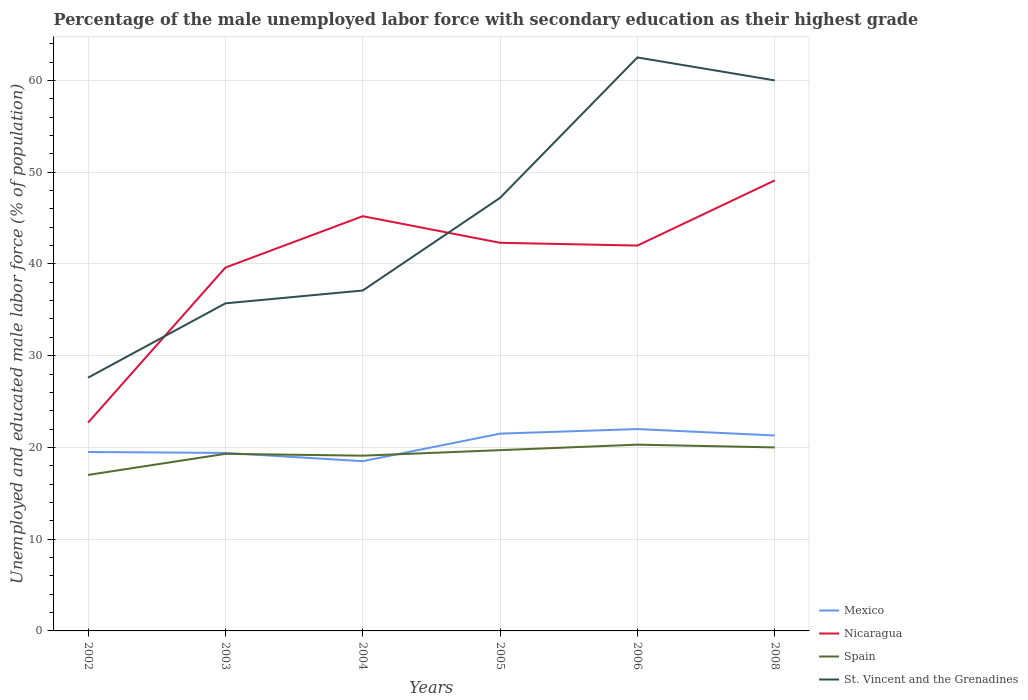How many different coloured lines are there?
Your answer should be very brief. 4. Across all years, what is the maximum percentage of the unemployed male labor force with secondary education in St. Vincent and the Grenadines?
Provide a short and direct response. 27.6. What is the total percentage of the unemployed male labor force with secondary education in Mexico in the graph?
Your response must be concise. 0.2. Is the percentage of the unemployed male labor force with secondary education in Mexico strictly greater than the percentage of the unemployed male labor force with secondary education in Spain over the years?
Give a very brief answer. No. How many years are there in the graph?
Ensure brevity in your answer.  6. Does the graph contain any zero values?
Your response must be concise. No. Where does the legend appear in the graph?
Offer a terse response. Bottom right. How are the legend labels stacked?
Your answer should be compact. Vertical. What is the title of the graph?
Offer a terse response. Percentage of the male unemployed labor force with secondary education as their highest grade. Does "Korea (Republic)" appear as one of the legend labels in the graph?
Provide a short and direct response. No. What is the label or title of the X-axis?
Provide a short and direct response. Years. What is the label or title of the Y-axis?
Your response must be concise. Unemployed and educated male labor force (% of population). What is the Unemployed and educated male labor force (% of population) of Nicaragua in 2002?
Offer a very short reply. 22.7. What is the Unemployed and educated male labor force (% of population) in St. Vincent and the Grenadines in 2002?
Offer a very short reply. 27.6. What is the Unemployed and educated male labor force (% of population) of Mexico in 2003?
Give a very brief answer. 19.4. What is the Unemployed and educated male labor force (% of population) in Nicaragua in 2003?
Your answer should be compact. 39.6. What is the Unemployed and educated male labor force (% of population) of Spain in 2003?
Your response must be concise. 19.3. What is the Unemployed and educated male labor force (% of population) of St. Vincent and the Grenadines in 2003?
Offer a terse response. 35.7. What is the Unemployed and educated male labor force (% of population) in Nicaragua in 2004?
Your response must be concise. 45.2. What is the Unemployed and educated male labor force (% of population) in Spain in 2004?
Your answer should be compact. 19.1. What is the Unemployed and educated male labor force (% of population) of St. Vincent and the Grenadines in 2004?
Provide a succinct answer. 37.1. What is the Unemployed and educated male labor force (% of population) in Nicaragua in 2005?
Your answer should be compact. 42.3. What is the Unemployed and educated male labor force (% of population) of Spain in 2005?
Your answer should be very brief. 19.7. What is the Unemployed and educated male labor force (% of population) in St. Vincent and the Grenadines in 2005?
Offer a very short reply. 47.2. What is the Unemployed and educated male labor force (% of population) of Spain in 2006?
Your answer should be compact. 20.3. What is the Unemployed and educated male labor force (% of population) in St. Vincent and the Grenadines in 2006?
Your answer should be compact. 62.5. What is the Unemployed and educated male labor force (% of population) of Mexico in 2008?
Your response must be concise. 21.3. What is the Unemployed and educated male labor force (% of population) in Nicaragua in 2008?
Offer a very short reply. 49.1. Across all years, what is the maximum Unemployed and educated male labor force (% of population) in Nicaragua?
Make the answer very short. 49.1. Across all years, what is the maximum Unemployed and educated male labor force (% of population) in Spain?
Your answer should be compact. 20.3. Across all years, what is the maximum Unemployed and educated male labor force (% of population) in St. Vincent and the Grenadines?
Your response must be concise. 62.5. Across all years, what is the minimum Unemployed and educated male labor force (% of population) of Nicaragua?
Your answer should be compact. 22.7. Across all years, what is the minimum Unemployed and educated male labor force (% of population) of Spain?
Your answer should be very brief. 17. Across all years, what is the minimum Unemployed and educated male labor force (% of population) in St. Vincent and the Grenadines?
Your answer should be very brief. 27.6. What is the total Unemployed and educated male labor force (% of population) of Mexico in the graph?
Offer a terse response. 122.2. What is the total Unemployed and educated male labor force (% of population) in Nicaragua in the graph?
Keep it short and to the point. 240.9. What is the total Unemployed and educated male labor force (% of population) in Spain in the graph?
Make the answer very short. 115.4. What is the total Unemployed and educated male labor force (% of population) of St. Vincent and the Grenadines in the graph?
Offer a terse response. 270.1. What is the difference between the Unemployed and educated male labor force (% of population) of Mexico in 2002 and that in 2003?
Your answer should be compact. 0.1. What is the difference between the Unemployed and educated male labor force (% of population) of Nicaragua in 2002 and that in 2003?
Ensure brevity in your answer.  -16.9. What is the difference between the Unemployed and educated male labor force (% of population) in Spain in 2002 and that in 2003?
Make the answer very short. -2.3. What is the difference between the Unemployed and educated male labor force (% of population) of St. Vincent and the Grenadines in 2002 and that in 2003?
Provide a short and direct response. -8.1. What is the difference between the Unemployed and educated male labor force (% of population) of Nicaragua in 2002 and that in 2004?
Provide a short and direct response. -22.5. What is the difference between the Unemployed and educated male labor force (% of population) of St. Vincent and the Grenadines in 2002 and that in 2004?
Your answer should be compact. -9.5. What is the difference between the Unemployed and educated male labor force (% of population) of Nicaragua in 2002 and that in 2005?
Offer a very short reply. -19.6. What is the difference between the Unemployed and educated male labor force (% of population) in St. Vincent and the Grenadines in 2002 and that in 2005?
Your answer should be very brief. -19.6. What is the difference between the Unemployed and educated male labor force (% of population) of Nicaragua in 2002 and that in 2006?
Provide a succinct answer. -19.3. What is the difference between the Unemployed and educated male labor force (% of population) in Spain in 2002 and that in 2006?
Give a very brief answer. -3.3. What is the difference between the Unemployed and educated male labor force (% of population) in St. Vincent and the Grenadines in 2002 and that in 2006?
Give a very brief answer. -34.9. What is the difference between the Unemployed and educated male labor force (% of population) of Mexico in 2002 and that in 2008?
Ensure brevity in your answer.  -1.8. What is the difference between the Unemployed and educated male labor force (% of population) in Nicaragua in 2002 and that in 2008?
Provide a succinct answer. -26.4. What is the difference between the Unemployed and educated male labor force (% of population) of St. Vincent and the Grenadines in 2002 and that in 2008?
Give a very brief answer. -32.4. What is the difference between the Unemployed and educated male labor force (% of population) in Mexico in 2003 and that in 2005?
Your answer should be very brief. -2.1. What is the difference between the Unemployed and educated male labor force (% of population) in Nicaragua in 2003 and that in 2005?
Your answer should be very brief. -2.7. What is the difference between the Unemployed and educated male labor force (% of population) of Spain in 2003 and that in 2005?
Give a very brief answer. -0.4. What is the difference between the Unemployed and educated male labor force (% of population) in Mexico in 2003 and that in 2006?
Ensure brevity in your answer.  -2.6. What is the difference between the Unemployed and educated male labor force (% of population) of St. Vincent and the Grenadines in 2003 and that in 2006?
Keep it short and to the point. -26.8. What is the difference between the Unemployed and educated male labor force (% of population) of Mexico in 2003 and that in 2008?
Your response must be concise. -1.9. What is the difference between the Unemployed and educated male labor force (% of population) of Nicaragua in 2003 and that in 2008?
Keep it short and to the point. -9.5. What is the difference between the Unemployed and educated male labor force (% of population) of St. Vincent and the Grenadines in 2003 and that in 2008?
Give a very brief answer. -24.3. What is the difference between the Unemployed and educated male labor force (% of population) of Nicaragua in 2004 and that in 2005?
Your answer should be compact. 2.9. What is the difference between the Unemployed and educated male labor force (% of population) in Spain in 2004 and that in 2005?
Make the answer very short. -0.6. What is the difference between the Unemployed and educated male labor force (% of population) of Mexico in 2004 and that in 2006?
Offer a terse response. -3.5. What is the difference between the Unemployed and educated male labor force (% of population) in St. Vincent and the Grenadines in 2004 and that in 2006?
Ensure brevity in your answer.  -25.4. What is the difference between the Unemployed and educated male labor force (% of population) in Nicaragua in 2004 and that in 2008?
Give a very brief answer. -3.9. What is the difference between the Unemployed and educated male labor force (% of population) of Spain in 2004 and that in 2008?
Offer a terse response. -0.9. What is the difference between the Unemployed and educated male labor force (% of population) in St. Vincent and the Grenadines in 2004 and that in 2008?
Provide a short and direct response. -22.9. What is the difference between the Unemployed and educated male labor force (% of population) of Mexico in 2005 and that in 2006?
Give a very brief answer. -0.5. What is the difference between the Unemployed and educated male labor force (% of population) of Nicaragua in 2005 and that in 2006?
Your answer should be very brief. 0.3. What is the difference between the Unemployed and educated male labor force (% of population) in Spain in 2005 and that in 2006?
Offer a very short reply. -0.6. What is the difference between the Unemployed and educated male labor force (% of population) in St. Vincent and the Grenadines in 2005 and that in 2006?
Offer a terse response. -15.3. What is the difference between the Unemployed and educated male labor force (% of population) of Mexico in 2005 and that in 2008?
Offer a very short reply. 0.2. What is the difference between the Unemployed and educated male labor force (% of population) in Nicaragua in 2005 and that in 2008?
Ensure brevity in your answer.  -6.8. What is the difference between the Unemployed and educated male labor force (% of population) of St. Vincent and the Grenadines in 2005 and that in 2008?
Keep it short and to the point. -12.8. What is the difference between the Unemployed and educated male labor force (% of population) in Nicaragua in 2006 and that in 2008?
Your answer should be compact. -7.1. What is the difference between the Unemployed and educated male labor force (% of population) in Mexico in 2002 and the Unemployed and educated male labor force (% of population) in Nicaragua in 2003?
Your answer should be compact. -20.1. What is the difference between the Unemployed and educated male labor force (% of population) of Mexico in 2002 and the Unemployed and educated male labor force (% of population) of St. Vincent and the Grenadines in 2003?
Ensure brevity in your answer.  -16.2. What is the difference between the Unemployed and educated male labor force (% of population) of Nicaragua in 2002 and the Unemployed and educated male labor force (% of population) of Spain in 2003?
Offer a very short reply. 3.4. What is the difference between the Unemployed and educated male labor force (% of population) of Spain in 2002 and the Unemployed and educated male labor force (% of population) of St. Vincent and the Grenadines in 2003?
Your response must be concise. -18.7. What is the difference between the Unemployed and educated male labor force (% of population) of Mexico in 2002 and the Unemployed and educated male labor force (% of population) of Nicaragua in 2004?
Provide a succinct answer. -25.7. What is the difference between the Unemployed and educated male labor force (% of population) in Mexico in 2002 and the Unemployed and educated male labor force (% of population) in St. Vincent and the Grenadines in 2004?
Your response must be concise. -17.6. What is the difference between the Unemployed and educated male labor force (% of population) of Nicaragua in 2002 and the Unemployed and educated male labor force (% of population) of St. Vincent and the Grenadines in 2004?
Provide a short and direct response. -14.4. What is the difference between the Unemployed and educated male labor force (% of population) in Spain in 2002 and the Unemployed and educated male labor force (% of population) in St. Vincent and the Grenadines in 2004?
Your response must be concise. -20.1. What is the difference between the Unemployed and educated male labor force (% of population) in Mexico in 2002 and the Unemployed and educated male labor force (% of population) in Nicaragua in 2005?
Provide a short and direct response. -22.8. What is the difference between the Unemployed and educated male labor force (% of population) of Mexico in 2002 and the Unemployed and educated male labor force (% of population) of Spain in 2005?
Your answer should be compact. -0.2. What is the difference between the Unemployed and educated male labor force (% of population) of Mexico in 2002 and the Unemployed and educated male labor force (% of population) of St. Vincent and the Grenadines in 2005?
Offer a terse response. -27.7. What is the difference between the Unemployed and educated male labor force (% of population) of Nicaragua in 2002 and the Unemployed and educated male labor force (% of population) of St. Vincent and the Grenadines in 2005?
Your answer should be compact. -24.5. What is the difference between the Unemployed and educated male labor force (% of population) in Spain in 2002 and the Unemployed and educated male labor force (% of population) in St. Vincent and the Grenadines in 2005?
Ensure brevity in your answer.  -30.2. What is the difference between the Unemployed and educated male labor force (% of population) of Mexico in 2002 and the Unemployed and educated male labor force (% of population) of Nicaragua in 2006?
Make the answer very short. -22.5. What is the difference between the Unemployed and educated male labor force (% of population) of Mexico in 2002 and the Unemployed and educated male labor force (% of population) of Spain in 2006?
Your answer should be very brief. -0.8. What is the difference between the Unemployed and educated male labor force (% of population) in Mexico in 2002 and the Unemployed and educated male labor force (% of population) in St. Vincent and the Grenadines in 2006?
Offer a very short reply. -43. What is the difference between the Unemployed and educated male labor force (% of population) of Nicaragua in 2002 and the Unemployed and educated male labor force (% of population) of St. Vincent and the Grenadines in 2006?
Ensure brevity in your answer.  -39.8. What is the difference between the Unemployed and educated male labor force (% of population) of Spain in 2002 and the Unemployed and educated male labor force (% of population) of St. Vincent and the Grenadines in 2006?
Offer a very short reply. -45.5. What is the difference between the Unemployed and educated male labor force (% of population) of Mexico in 2002 and the Unemployed and educated male labor force (% of population) of Nicaragua in 2008?
Give a very brief answer. -29.6. What is the difference between the Unemployed and educated male labor force (% of population) in Mexico in 2002 and the Unemployed and educated male labor force (% of population) in St. Vincent and the Grenadines in 2008?
Ensure brevity in your answer.  -40.5. What is the difference between the Unemployed and educated male labor force (% of population) in Nicaragua in 2002 and the Unemployed and educated male labor force (% of population) in Spain in 2008?
Ensure brevity in your answer.  2.7. What is the difference between the Unemployed and educated male labor force (% of population) in Nicaragua in 2002 and the Unemployed and educated male labor force (% of population) in St. Vincent and the Grenadines in 2008?
Your answer should be compact. -37.3. What is the difference between the Unemployed and educated male labor force (% of population) in Spain in 2002 and the Unemployed and educated male labor force (% of population) in St. Vincent and the Grenadines in 2008?
Your answer should be very brief. -43. What is the difference between the Unemployed and educated male labor force (% of population) of Mexico in 2003 and the Unemployed and educated male labor force (% of population) of Nicaragua in 2004?
Make the answer very short. -25.8. What is the difference between the Unemployed and educated male labor force (% of population) in Mexico in 2003 and the Unemployed and educated male labor force (% of population) in St. Vincent and the Grenadines in 2004?
Keep it short and to the point. -17.7. What is the difference between the Unemployed and educated male labor force (% of population) in Nicaragua in 2003 and the Unemployed and educated male labor force (% of population) in Spain in 2004?
Give a very brief answer. 20.5. What is the difference between the Unemployed and educated male labor force (% of population) of Nicaragua in 2003 and the Unemployed and educated male labor force (% of population) of St. Vincent and the Grenadines in 2004?
Make the answer very short. 2.5. What is the difference between the Unemployed and educated male labor force (% of population) of Spain in 2003 and the Unemployed and educated male labor force (% of population) of St. Vincent and the Grenadines in 2004?
Your answer should be very brief. -17.8. What is the difference between the Unemployed and educated male labor force (% of population) of Mexico in 2003 and the Unemployed and educated male labor force (% of population) of Nicaragua in 2005?
Your response must be concise. -22.9. What is the difference between the Unemployed and educated male labor force (% of population) in Mexico in 2003 and the Unemployed and educated male labor force (% of population) in St. Vincent and the Grenadines in 2005?
Give a very brief answer. -27.8. What is the difference between the Unemployed and educated male labor force (% of population) of Nicaragua in 2003 and the Unemployed and educated male labor force (% of population) of Spain in 2005?
Provide a succinct answer. 19.9. What is the difference between the Unemployed and educated male labor force (% of population) of Spain in 2003 and the Unemployed and educated male labor force (% of population) of St. Vincent and the Grenadines in 2005?
Provide a short and direct response. -27.9. What is the difference between the Unemployed and educated male labor force (% of population) of Mexico in 2003 and the Unemployed and educated male labor force (% of population) of Nicaragua in 2006?
Keep it short and to the point. -22.6. What is the difference between the Unemployed and educated male labor force (% of population) of Mexico in 2003 and the Unemployed and educated male labor force (% of population) of St. Vincent and the Grenadines in 2006?
Keep it short and to the point. -43.1. What is the difference between the Unemployed and educated male labor force (% of population) in Nicaragua in 2003 and the Unemployed and educated male labor force (% of population) in Spain in 2006?
Your response must be concise. 19.3. What is the difference between the Unemployed and educated male labor force (% of population) of Nicaragua in 2003 and the Unemployed and educated male labor force (% of population) of St. Vincent and the Grenadines in 2006?
Provide a short and direct response. -22.9. What is the difference between the Unemployed and educated male labor force (% of population) of Spain in 2003 and the Unemployed and educated male labor force (% of population) of St. Vincent and the Grenadines in 2006?
Give a very brief answer. -43.2. What is the difference between the Unemployed and educated male labor force (% of population) of Mexico in 2003 and the Unemployed and educated male labor force (% of population) of Nicaragua in 2008?
Keep it short and to the point. -29.7. What is the difference between the Unemployed and educated male labor force (% of population) of Mexico in 2003 and the Unemployed and educated male labor force (% of population) of Spain in 2008?
Your answer should be very brief. -0.6. What is the difference between the Unemployed and educated male labor force (% of population) of Mexico in 2003 and the Unemployed and educated male labor force (% of population) of St. Vincent and the Grenadines in 2008?
Provide a succinct answer. -40.6. What is the difference between the Unemployed and educated male labor force (% of population) in Nicaragua in 2003 and the Unemployed and educated male labor force (% of population) in Spain in 2008?
Offer a terse response. 19.6. What is the difference between the Unemployed and educated male labor force (% of population) of Nicaragua in 2003 and the Unemployed and educated male labor force (% of population) of St. Vincent and the Grenadines in 2008?
Provide a short and direct response. -20.4. What is the difference between the Unemployed and educated male labor force (% of population) of Spain in 2003 and the Unemployed and educated male labor force (% of population) of St. Vincent and the Grenadines in 2008?
Make the answer very short. -40.7. What is the difference between the Unemployed and educated male labor force (% of population) of Mexico in 2004 and the Unemployed and educated male labor force (% of population) of Nicaragua in 2005?
Provide a short and direct response. -23.8. What is the difference between the Unemployed and educated male labor force (% of population) of Mexico in 2004 and the Unemployed and educated male labor force (% of population) of St. Vincent and the Grenadines in 2005?
Offer a very short reply. -28.7. What is the difference between the Unemployed and educated male labor force (% of population) of Spain in 2004 and the Unemployed and educated male labor force (% of population) of St. Vincent and the Grenadines in 2005?
Make the answer very short. -28.1. What is the difference between the Unemployed and educated male labor force (% of population) of Mexico in 2004 and the Unemployed and educated male labor force (% of population) of Nicaragua in 2006?
Make the answer very short. -23.5. What is the difference between the Unemployed and educated male labor force (% of population) in Mexico in 2004 and the Unemployed and educated male labor force (% of population) in St. Vincent and the Grenadines in 2006?
Give a very brief answer. -44. What is the difference between the Unemployed and educated male labor force (% of population) of Nicaragua in 2004 and the Unemployed and educated male labor force (% of population) of Spain in 2006?
Your response must be concise. 24.9. What is the difference between the Unemployed and educated male labor force (% of population) in Nicaragua in 2004 and the Unemployed and educated male labor force (% of population) in St. Vincent and the Grenadines in 2006?
Make the answer very short. -17.3. What is the difference between the Unemployed and educated male labor force (% of population) in Spain in 2004 and the Unemployed and educated male labor force (% of population) in St. Vincent and the Grenadines in 2006?
Your response must be concise. -43.4. What is the difference between the Unemployed and educated male labor force (% of population) in Mexico in 2004 and the Unemployed and educated male labor force (% of population) in Nicaragua in 2008?
Your answer should be compact. -30.6. What is the difference between the Unemployed and educated male labor force (% of population) in Mexico in 2004 and the Unemployed and educated male labor force (% of population) in Spain in 2008?
Give a very brief answer. -1.5. What is the difference between the Unemployed and educated male labor force (% of population) in Mexico in 2004 and the Unemployed and educated male labor force (% of population) in St. Vincent and the Grenadines in 2008?
Your answer should be very brief. -41.5. What is the difference between the Unemployed and educated male labor force (% of population) of Nicaragua in 2004 and the Unemployed and educated male labor force (% of population) of Spain in 2008?
Offer a terse response. 25.2. What is the difference between the Unemployed and educated male labor force (% of population) in Nicaragua in 2004 and the Unemployed and educated male labor force (% of population) in St. Vincent and the Grenadines in 2008?
Provide a short and direct response. -14.8. What is the difference between the Unemployed and educated male labor force (% of population) of Spain in 2004 and the Unemployed and educated male labor force (% of population) of St. Vincent and the Grenadines in 2008?
Ensure brevity in your answer.  -40.9. What is the difference between the Unemployed and educated male labor force (% of population) in Mexico in 2005 and the Unemployed and educated male labor force (% of population) in Nicaragua in 2006?
Give a very brief answer. -20.5. What is the difference between the Unemployed and educated male labor force (% of population) of Mexico in 2005 and the Unemployed and educated male labor force (% of population) of St. Vincent and the Grenadines in 2006?
Your answer should be very brief. -41. What is the difference between the Unemployed and educated male labor force (% of population) of Nicaragua in 2005 and the Unemployed and educated male labor force (% of population) of St. Vincent and the Grenadines in 2006?
Provide a short and direct response. -20.2. What is the difference between the Unemployed and educated male labor force (% of population) in Spain in 2005 and the Unemployed and educated male labor force (% of population) in St. Vincent and the Grenadines in 2006?
Ensure brevity in your answer.  -42.8. What is the difference between the Unemployed and educated male labor force (% of population) in Mexico in 2005 and the Unemployed and educated male labor force (% of population) in Nicaragua in 2008?
Provide a succinct answer. -27.6. What is the difference between the Unemployed and educated male labor force (% of population) of Mexico in 2005 and the Unemployed and educated male labor force (% of population) of Spain in 2008?
Ensure brevity in your answer.  1.5. What is the difference between the Unemployed and educated male labor force (% of population) in Mexico in 2005 and the Unemployed and educated male labor force (% of population) in St. Vincent and the Grenadines in 2008?
Ensure brevity in your answer.  -38.5. What is the difference between the Unemployed and educated male labor force (% of population) in Nicaragua in 2005 and the Unemployed and educated male labor force (% of population) in Spain in 2008?
Offer a terse response. 22.3. What is the difference between the Unemployed and educated male labor force (% of population) of Nicaragua in 2005 and the Unemployed and educated male labor force (% of population) of St. Vincent and the Grenadines in 2008?
Give a very brief answer. -17.7. What is the difference between the Unemployed and educated male labor force (% of population) of Spain in 2005 and the Unemployed and educated male labor force (% of population) of St. Vincent and the Grenadines in 2008?
Your response must be concise. -40.3. What is the difference between the Unemployed and educated male labor force (% of population) of Mexico in 2006 and the Unemployed and educated male labor force (% of population) of Nicaragua in 2008?
Your answer should be very brief. -27.1. What is the difference between the Unemployed and educated male labor force (% of population) of Mexico in 2006 and the Unemployed and educated male labor force (% of population) of Spain in 2008?
Provide a short and direct response. 2. What is the difference between the Unemployed and educated male labor force (% of population) of Mexico in 2006 and the Unemployed and educated male labor force (% of population) of St. Vincent and the Grenadines in 2008?
Provide a short and direct response. -38. What is the difference between the Unemployed and educated male labor force (% of population) of Spain in 2006 and the Unemployed and educated male labor force (% of population) of St. Vincent and the Grenadines in 2008?
Your response must be concise. -39.7. What is the average Unemployed and educated male labor force (% of population) of Mexico per year?
Keep it short and to the point. 20.37. What is the average Unemployed and educated male labor force (% of population) of Nicaragua per year?
Your response must be concise. 40.15. What is the average Unemployed and educated male labor force (% of population) in Spain per year?
Offer a terse response. 19.23. What is the average Unemployed and educated male labor force (% of population) of St. Vincent and the Grenadines per year?
Offer a terse response. 45.02. In the year 2002, what is the difference between the Unemployed and educated male labor force (% of population) in Mexico and Unemployed and educated male labor force (% of population) in Nicaragua?
Offer a terse response. -3.2. In the year 2002, what is the difference between the Unemployed and educated male labor force (% of population) in Mexico and Unemployed and educated male labor force (% of population) in Spain?
Offer a terse response. 2.5. In the year 2002, what is the difference between the Unemployed and educated male labor force (% of population) of Nicaragua and Unemployed and educated male labor force (% of population) of Spain?
Offer a very short reply. 5.7. In the year 2003, what is the difference between the Unemployed and educated male labor force (% of population) in Mexico and Unemployed and educated male labor force (% of population) in Nicaragua?
Give a very brief answer. -20.2. In the year 2003, what is the difference between the Unemployed and educated male labor force (% of population) in Mexico and Unemployed and educated male labor force (% of population) in Spain?
Ensure brevity in your answer.  0.1. In the year 2003, what is the difference between the Unemployed and educated male labor force (% of population) in Mexico and Unemployed and educated male labor force (% of population) in St. Vincent and the Grenadines?
Your response must be concise. -16.3. In the year 2003, what is the difference between the Unemployed and educated male labor force (% of population) in Nicaragua and Unemployed and educated male labor force (% of population) in Spain?
Your response must be concise. 20.3. In the year 2003, what is the difference between the Unemployed and educated male labor force (% of population) of Nicaragua and Unemployed and educated male labor force (% of population) of St. Vincent and the Grenadines?
Provide a short and direct response. 3.9. In the year 2003, what is the difference between the Unemployed and educated male labor force (% of population) in Spain and Unemployed and educated male labor force (% of population) in St. Vincent and the Grenadines?
Provide a succinct answer. -16.4. In the year 2004, what is the difference between the Unemployed and educated male labor force (% of population) in Mexico and Unemployed and educated male labor force (% of population) in Nicaragua?
Keep it short and to the point. -26.7. In the year 2004, what is the difference between the Unemployed and educated male labor force (% of population) of Mexico and Unemployed and educated male labor force (% of population) of St. Vincent and the Grenadines?
Your answer should be compact. -18.6. In the year 2004, what is the difference between the Unemployed and educated male labor force (% of population) in Nicaragua and Unemployed and educated male labor force (% of population) in Spain?
Keep it short and to the point. 26.1. In the year 2004, what is the difference between the Unemployed and educated male labor force (% of population) in Nicaragua and Unemployed and educated male labor force (% of population) in St. Vincent and the Grenadines?
Make the answer very short. 8.1. In the year 2004, what is the difference between the Unemployed and educated male labor force (% of population) of Spain and Unemployed and educated male labor force (% of population) of St. Vincent and the Grenadines?
Provide a short and direct response. -18. In the year 2005, what is the difference between the Unemployed and educated male labor force (% of population) of Mexico and Unemployed and educated male labor force (% of population) of Nicaragua?
Offer a very short reply. -20.8. In the year 2005, what is the difference between the Unemployed and educated male labor force (% of population) of Mexico and Unemployed and educated male labor force (% of population) of Spain?
Provide a succinct answer. 1.8. In the year 2005, what is the difference between the Unemployed and educated male labor force (% of population) in Mexico and Unemployed and educated male labor force (% of population) in St. Vincent and the Grenadines?
Provide a short and direct response. -25.7. In the year 2005, what is the difference between the Unemployed and educated male labor force (% of population) in Nicaragua and Unemployed and educated male labor force (% of population) in Spain?
Ensure brevity in your answer.  22.6. In the year 2005, what is the difference between the Unemployed and educated male labor force (% of population) in Spain and Unemployed and educated male labor force (% of population) in St. Vincent and the Grenadines?
Offer a terse response. -27.5. In the year 2006, what is the difference between the Unemployed and educated male labor force (% of population) in Mexico and Unemployed and educated male labor force (% of population) in Spain?
Provide a succinct answer. 1.7. In the year 2006, what is the difference between the Unemployed and educated male labor force (% of population) in Mexico and Unemployed and educated male labor force (% of population) in St. Vincent and the Grenadines?
Provide a short and direct response. -40.5. In the year 2006, what is the difference between the Unemployed and educated male labor force (% of population) in Nicaragua and Unemployed and educated male labor force (% of population) in Spain?
Ensure brevity in your answer.  21.7. In the year 2006, what is the difference between the Unemployed and educated male labor force (% of population) of Nicaragua and Unemployed and educated male labor force (% of population) of St. Vincent and the Grenadines?
Provide a succinct answer. -20.5. In the year 2006, what is the difference between the Unemployed and educated male labor force (% of population) in Spain and Unemployed and educated male labor force (% of population) in St. Vincent and the Grenadines?
Your response must be concise. -42.2. In the year 2008, what is the difference between the Unemployed and educated male labor force (% of population) of Mexico and Unemployed and educated male labor force (% of population) of Nicaragua?
Provide a succinct answer. -27.8. In the year 2008, what is the difference between the Unemployed and educated male labor force (% of population) in Mexico and Unemployed and educated male labor force (% of population) in Spain?
Provide a succinct answer. 1.3. In the year 2008, what is the difference between the Unemployed and educated male labor force (% of population) in Mexico and Unemployed and educated male labor force (% of population) in St. Vincent and the Grenadines?
Give a very brief answer. -38.7. In the year 2008, what is the difference between the Unemployed and educated male labor force (% of population) of Nicaragua and Unemployed and educated male labor force (% of population) of Spain?
Ensure brevity in your answer.  29.1. In the year 2008, what is the difference between the Unemployed and educated male labor force (% of population) of Nicaragua and Unemployed and educated male labor force (% of population) of St. Vincent and the Grenadines?
Provide a succinct answer. -10.9. What is the ratio of the Unemployed and educated male labor force (% of population) of Nicaragua in 2002 to that in 2003?
Offer a very short reply. 0.57. What is the ratio of the Unemployed and educated male labor force (% of population) in Spain in 2002 to that in 2003?
Provide a short and direct response. 0.88. What is the ratio of the Unemployed and educated male labor force (% of population) of St. Vincent and the Grenadines in 2002 to that in 2003?
Your answer should be compact. 0.77. What is the ratio of the Unemployed and educated male labor force (% of population) of Mexico in 2002 to that in 2004?
Your response must be concise. 1.05. What is the ratio of the Unemployed and educated male labor force (% of population) of Nicaragua in 2002 to that in 2004?
Keep it short and to the point. 0.5. What is the ratio of the Unemployed and educated male labor force (% of population) in Spain in 2002 to that in 2004?
Your answer should be very brief. 0.89. What is the ratio of the Unemployed and educated male labor force (% of population) of St. Vincent and the Grenadines in 2002 to that in 2004?
Give a very brief answer. 0.74. What is the ratio of the Unemployed and educated male labor force (% of population) of Mexico in 2002 to that in 2005?
Provide a short and direct response. 0.91. What is the ratio of the Unemployed and educated male labor force (% of population) in Nicaragua in 2002 to that in 2005?
Make the answer very short. 0.54. What is the ratio of the Unemployed and educated male labor force (% of population) in Spain in 2002 to that in 2005?
Your answer should be compact. 0.86. What is the ratio of the Unemployed and educated male labor force (% of population) of St. Vincent and the Grenadines in 2002 to that in 2005?
Keep it short and to the point. 0.58. What is the ratio of the Unemployed and educated male labor force (% of population) in Mexico in 2002 to that in 2006?
Make the answer very short. 0.89. What is the ratio of the Unemployed and educated male labor force (% of population) of Nicaragua in 2002 to that in 2006?
Offer a terse response. 0.54. What is the ratio of the Unemployed and educated male labor force (% of population) of Spain in 2002 to that in 2006?
Keep it short and to the point. 0.84. What is the ratio of the Unemployed and educated male labor force (% of population) in St. Vincent and the Grenadines in 2002 to that in 2006?
Provide a short and direct response. 0.44. What is the ratio of the Unemployed and educated male labor force (% of population) in Mexico in 2002 to that in 2008?
Provide a succinct answer. 0.92. What is the ratio of the Unemployed and educated male labor force (% of population) of Nicaragua in 2002 to that in 2008?
Provide a short and direct response. 0.46. What is the ratio of the Unemployed and educated male labor force (% of population) in Spain in 2002 to that in 2008?
Provide a short and direct response. 0.85. What is the ratio of the Unemployed and educated male labor force (% of population) in St. Vincent and the Grenadines in 2002 to that in 2008?
Your answer should be compact. 0.46. What is the ratio of the Unemployed and educated male labor force (% of population) of Mexico in 2003 to that in 2004?
Offer a very short reply. 1.05. What is the ratio of the Unemployed and educated male labor force (% of population) in Nicaragua in 2003 to that in 2004?
Offer a very short reply. 0.88. What is the ratio of the Unemployed and educated male labor force (% of population) in Spain in 2003 to that in 2004?
Keep it short and to the point. 1.01. What is the ratio of the Unemployed and educated male labor force (% of population) of St. Vincent and the Grenadines in 2003 to that in 2004?
Your answer should be very brief. 0.96. What is the ratio of the Unemployed and educated male labor force (% of population) in Mexico in 2003 to that in 2005?
Your answer should be compact. 0.9. What is the ratio of the Unemployed and educated male labor force (% of population) in Nicaragua in 2003 to that in 2005?
Give a very brief answer. 0.94. What is the ratio of the Unemployed and educated male labor force (% of population) in Spain in 2003 to that in 2005?
Offer a very short reply. 0.98. What is the ratio of the Unemployed and educated male labor force (% of population) of St. Vincent and the Grenadines in 2003 to that in 2005?
Keep it short and to the point. 0.76. What is the ratio of the Unemployed and educated male labor force (% of population) in Mexico in 2003 to that in 2006?
Your answer should be compact. 0.88. What is the ratio of the Unemployed and educated male labor force (% of population) of Nicaragua in 2003 to that in 2006?
Your answer should be very brief. 0.94. What is the ratio of the Unemployed and educated male labor force (% of population) in Spain in 2003 to that in 2006?
Provide a short and direct response. 0.95. What is the ratio of the Unemployed and educated male labor force (% of population) in St. Vincent and the Grenadines in 2003 to that in 2006?
Your answer should be compact. 0.57. What is the ratio of the Unemployed and educated male labor force (% of population) in Mexico in 2003 to that in 2008?
Your response must be concise. 0.91. What is the ratio of the Unemployed and educated male labor force (% of population) in Nicaragua in 2003 to that in 2008?
Your response must be concise. 0.81. What is the ratio of the Unemployed and educated male labor force (% of population) in St. Vincent and the Grenadines in 2003 to that in 2008?
Offer a very short reply. 0.59. What is the ratio of the Unemployed and educated male labor force (% of population) of Mexico in 2004 to that in 2005?
Provide a short and direct response. 0.86. What is the ratio of the Unemployed and educated male labor force (% of population) in Nicaragua in 2004 to that in 2005?
Provide a short and direct response. 1.07. What is the ratio of the Unemployed and educated male labor force (% of population) in Spain in 2004 to that in 2005?
Your answer should be very brief. 0.97. What is the ratio of the Unemployed and educated male labor force (% of population) of St. Vincent and the Grenadines in 2004 to that in 2005?
Your response must be concise. 0.79. What is the ratio of the Unemployed and educated male labor force (% of population) of Mexico in 2004 to that in 2006?
Offer a very short reply. 0.84. What is the ratio of the Unemployed and educated male labor force (% of population) in Nicaragua in 2004 to that in 2006?
Ensure brevity in your answer.  1.08. What is the ratio of the Unemployed and educated male labor force (% of population) in Spain in 2004 to that in 2006?
Ensure brevity in your answer.  0.94. What is the ratio of the Unemployed and educated male labor force (% of population) of St. Vincent and the Grenadines in 2004 to that in 2006?
Provide a succinct answer. 0.59. What is the ratio of the Unemployed and educated male labor force (% of population) of Mexico in 2004 to that in 2008?
Your answer should be compact. 0.87. What is the ratio of the Unemployed and educated male labor force (% of population) in Nicaragua in 2004 to that in 2008?
Provide a succinct answer. 0.92. What is the ratio of the Unemployed and educated male labor force (% of population) of Spain in 2004 to that in 2008?
Provide a short and direct response. 0.95. What is the ratio of the Unemployed and educated male labor force (% of population) of St. Vincent and the Grenadines in 2004 to that in 2008?
Give a very brief answer. 0.62. What is the ratio of the Unemployed and educated male labor force (% of population) in Mexico in 2005 to that in 2006?
Give a very brief answer. 0.98. What is the ratio of the Unemployed and educated male labor force (% of population) of Nicaragua in 2005 to that in 2006?
Offer a terse response. 1.01. What is the ratio of the Unemployed and educated male labor force (% of population) of Spain in 2005 to that in 2006?
Your answer should be compact. 0.97. What is the ratio of the Unemployed and educated male labor force (% of population) of St. Vincent and the Grenadines in 2005 to that in 2006?
Provide a short and direct response. 0.76. What is the ratio of the Unemployed and educated male labor force (% of population) of Mexico in 2005 to that in 2008?
Offer a very short reply. 1.01. What is the ratio of the Unemployed and educated male labor force (% of population) in Nicaragua in 2005 to that in 2008?
Make the answer very short. 0.86. What is the ratio of the Unemployed and educated male labor force (% of population) in St. Vincent and the Grenadines in 2005 to that in 2008?
Offer a very short reply. 0.79. What is the ratio of the Unemployed and educated male labor force (% of population) in Mexico in 2006 to that in 2008?
Make the answer very short. 1.03. What is the ratio of the Unemployed and educated male labor force (% of population) of Nicaragua in 2006 to that in 2008?
Your answer should be very brief. 0.86. What is the ratio of the Unemployed and educated male labor force (% of population) in St. Vincent and the Grenadines in 2006 to that in 2008?
Offer a terse response. 1.04. What is the difference between the highest and the second highest Unemployed and educated male labor force (% of population) in Nicaragua?
Provide a short and direct response. 3.9. What is the difference between the highest and the second highest Unemployed and educated male labor force (% of population) of St. Vincent and the Grenadines?
Ensure brevity in your answer.  2.5. What is the difference between the highest and the lowest Unemployed and educated male labor force (% of population) in Mexico?
Ensure brevity in your answer.  3.5. What is the difference between the highest and the lowest Unemployed and educated male labor force (% of population) in Nicaragua?
Make the answer very short. 26.4. What is the difference between the highest and the lowest Unemployed and educated male labor force (% of population) in Spain?
Make the answer very short. 3.3. What is the difference between the highest and the lowest Unemployed and educated male labor force (% of population) in St. Vincent and the Grenadines?
Offer a terse response. 34.9. 